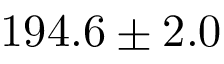Convert formula to latex. <formula><loc_0><loc_0><loc_500><loc_500>1 9 4 . 6 \pm 2 . 0</formula> 